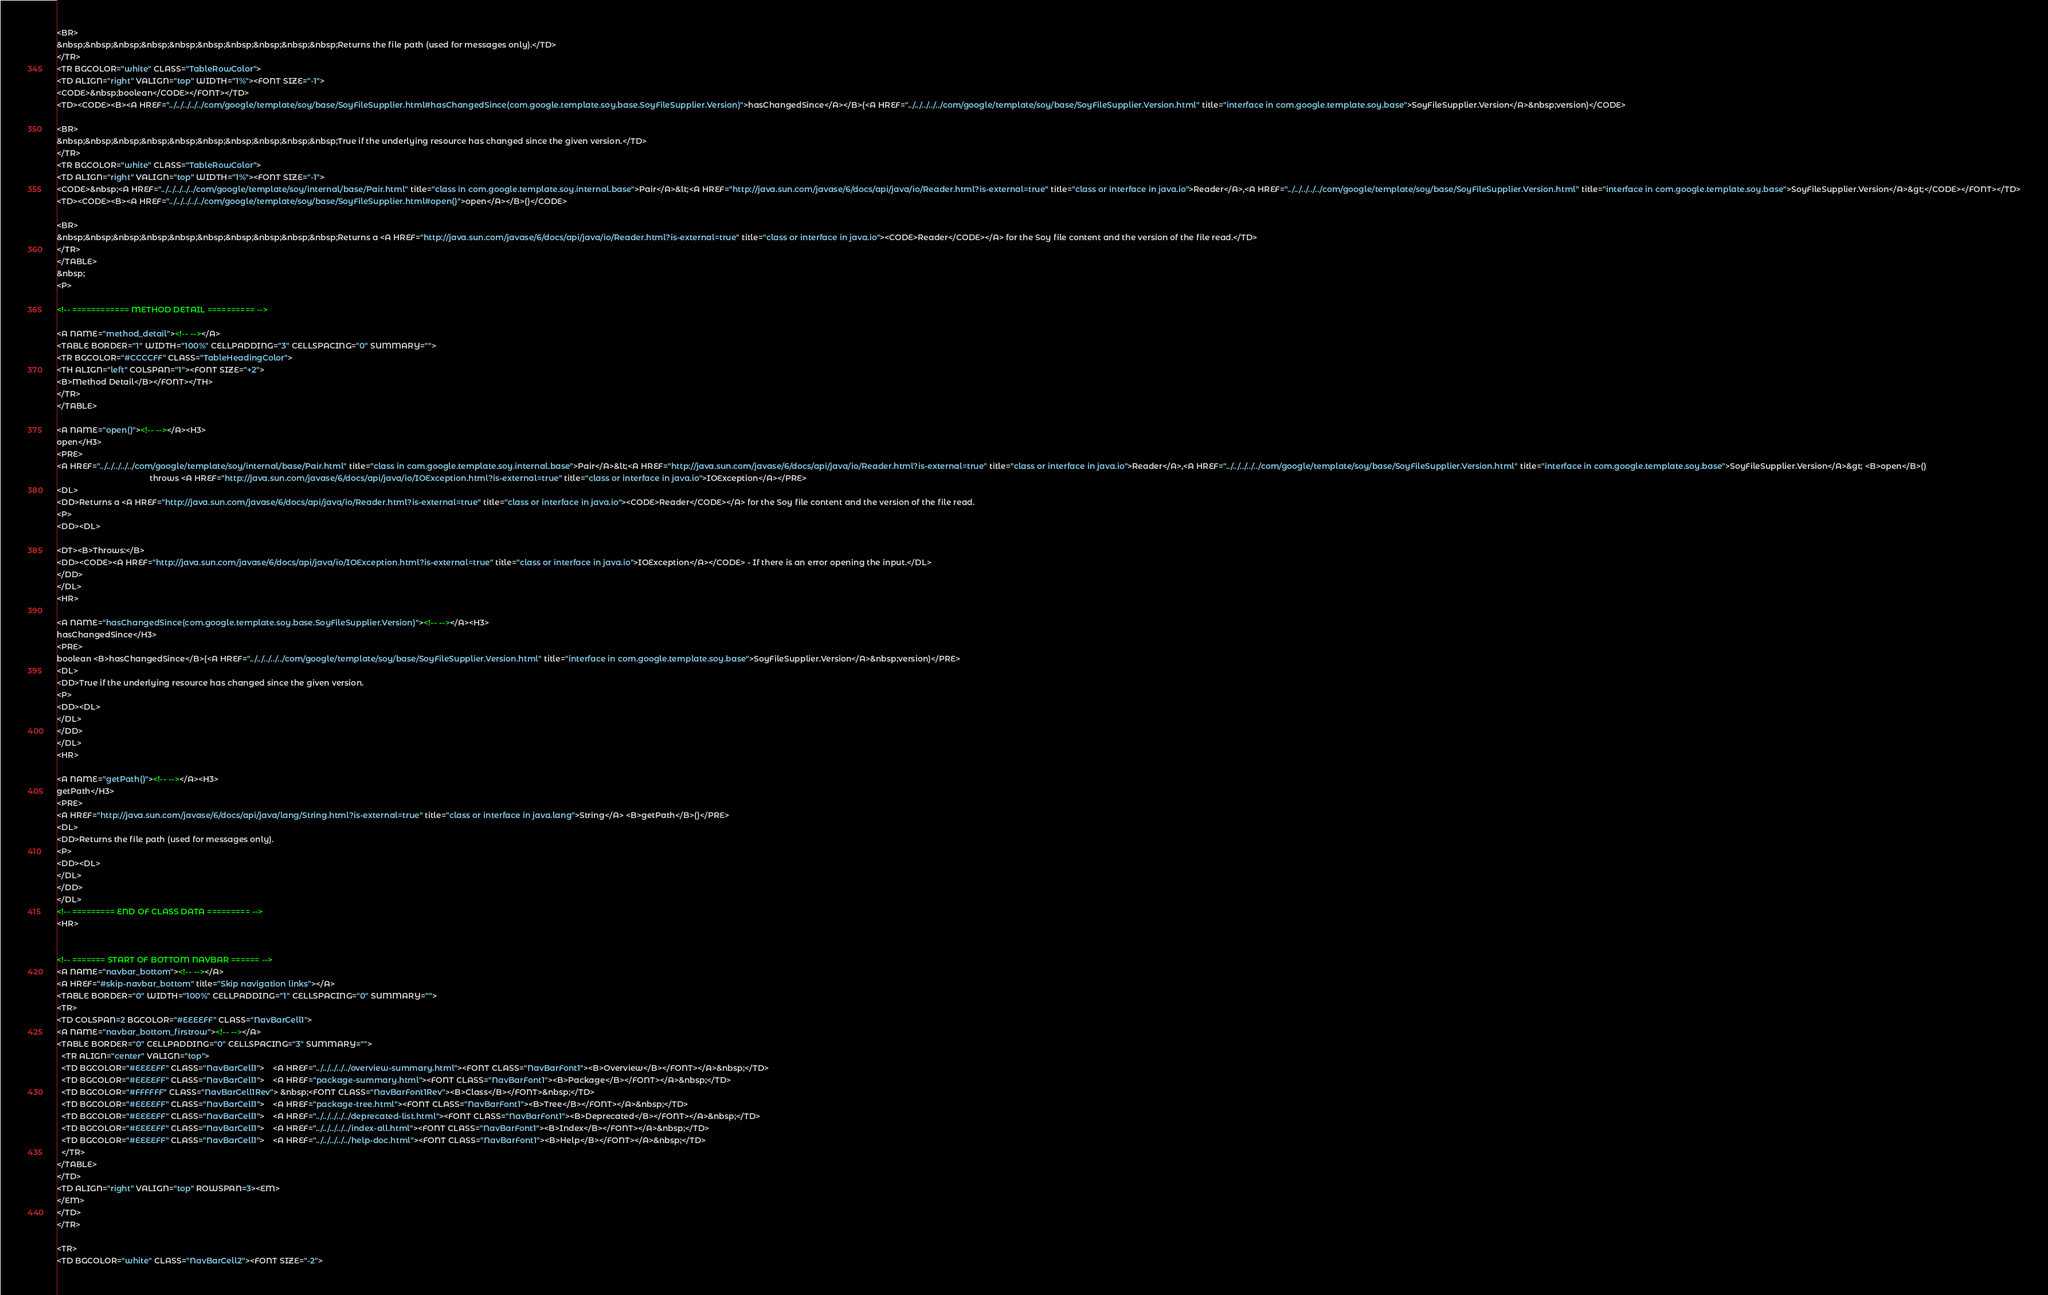Convert code to text. <code><loc_0><loc_0><loc_500><loc_500><_HTML_><BR>
&nbsp;&nbsp;&nbsp;&nbsp;&nbsp;&nbsp;&nbsp;&nbsp;&nbsp;&nbsp;Returns the file path (used for messages only).</TD>
</TR>
<TR BGCOLOR="white" CLASS="TableRowColor">
<TD ALIGN="right" VALIGN="top" WIDTH="1%"><FONT SIZE="-1">
<CODE>&nbsp;boolean</CODE></FONT></TD>
<TD><CODE><B><A HREF="../../../../../com/google/template/soy/base/SoyFileSupplier.html#hasChangedSince(com.google.template.soy.base.SoyFileSupplier.Version)">hasChangedSince</A></B>(<A HREF="../../../../../com/google/template/soy/base/SoyFileSupplier.Version.html" title="interface in com.google.template.soy.base">SoyFileSupplier.Version</A>&nbsp;version)</CODE>

<BR>
&nbsp;&nbsp;&nbsp;&nbsp;&nbsp;&nbsp;&nbsp;&nbsp;&nbsp;&nbsp;True if the underlying resource has changed since the given version.</TD>
</TR>
<TR BGCOLOR="white" CLASS="TableRowColor">
<TD ALIGN="right" VALIGN="top" WIDTH="1%"><FONT SIZE="-1">
<CODE>&nbsp;<A HREF="../../../../../com/google/template/soy/internal/base/Pair.html" title="class in com.google.template.soy.internal.base">Pair</A>&lt;<A HREF="http://java.sun.com/javase/6/docs/api/java/io/Reader.html?is-external=true" title="class or interface in java.io">Reader</A>,<A HREF="../../../../../com/google/template/soy/base/SoyFileSupplier.Version.html" title="interface in com.google.template.soy.base">SoyFileSupplier.Version</A>&gt;</CODE></FONT></TD>
<TD><CODE><B><A HREF="../../../../../com/google/template/soy/base/SoyFileSupplier.html#open()">open</A></B>()</CODE>

<BR>
&nbsp;&nbsp;&nbsp;&nbsp;&nbsp;&nbsp;&nbsp;&nbsp;&nbsp;&nbsp;Returns a <A HREF="http://java.sun.com/javase/6/docs/api/java/io/Reader.html?is-external=true" title="class or interface in java.io"><CODE>Reader</CODE></A> for the Soy file content and the version of the file read.</TD>
</TR>
</TABLE>
&nbsp;
<P>

<!-- ============ METHOD DETAIL ========== -->

<A NAME="method_detail"><!-- --></A>
<TABLE BORDER="1" WIDTH="100%" CELLPADDING="3" CELLSPACING="0" SUMMARY="">
<TR BGCOLOR="#CCCCFF" CLASS="TableHeadingColor">
<TH ALIGN="left" COLSPAN="1"><FONT SIZE="+2">
<B>Method Detail</B></FONT></TH>
</TR>
</TABLE>

<A NAME="open()"><!-- --></A><H3>
open</H3>
<PRE>
<A HREF="../../../../../com/google/template/soy/internal/base/Pair.html" title="class in com.google.template.soy.internal.base">Pair</A>&lt;<A HREF="http://java.sun.com/javase/6/docs/api/java/io/Reader.html?is-external=true" title="class or interface in java.io">Reader</A>,<A HREF="../../../../../com/google/template/soy/base/SoyFileSupplier.Version.html" title="interface in com.google.template.soy.base">SoyFileSupplier.Version</A>&gt; <B>open</B>()
                                          throws <A HREF="http://java.sun.com/javase/6/docs/api/java/io/IOException.html?is-external=true" title="class or interface in java.io">IOException</A></PRE>
<DL>
<DD>Returns a <A HREF="http://java.sun.com/javase/6/docs/api/java/io/Reader.html?is-external=true" title="class or interface in java.io"><CODE>Reader</CODE></A> for the Soy file content and the version of the file read.
<P>
<DD><DL>

<DT><B>Throws:</B>
<DD><CODE><A HREF="http://java.sun.com/javase/6/docs/api/java/io/IOException.html?is-external=true" title="class or interface in java.io">IOException</A></CODE> - If there is an error opening the input.</DL>
</DD>
</DL>
<HR>

<A NAME="hasChangedSince(com.google.template.soy.base.SoyFileSupplier.Version)"><!-- --></A><H3>
hasChangedSince</H3>
<PRE>
boolean <B>hasChangedSince</B>(<A HREF="../../../../../com/google/template/soy/base/SoyFileSupplier.Version.html" title="interface in com.google.template.soy.base">SoyFileSupplier.Version</A>&nbsp;version)</PRE>
<DL>
<DD>True if the underlying resource has changed since the given version.
<P>
<DD><DL>
</DL>
</DD>
</DL>
<HR>

<A NAME="getPath()"><!-- --></A><H3>
getPath</H3>
<PRE>
<A HREF="http://java.sun.com/javase/6/docs/api/java/lang/String.html?is-external=true" title="class or interface in java.lang">String</A> <B>getPath</B>()</PRE>
<DL>
<DD>Returns the file path (used for messages only).
<P>
<DD><DL>
</DL>
</DD>
</DL>
<!-- ========= END OF CLASS DATA ========= -->
<HR>


<!-- ======= START OF BOTTOM NAVBAR ====== -->
<A NAME="navbar_bottom"><!-- --></A>
<A HREF="#skip-navbar_bottom" title="Skip navigation links"></A>
<TABLE BORDER="0" WIDTH="100%" CELLPADDING="1" CELLSPACING="0" SUMMARY="">
<TR>
<TD COLSPAN=2 BGCOLOR="#EEEEFF" CLASS="NavBarCell1">
<A NAME="navbar_bottom_firstrow"><!-- --></A>
<TABLE BORDER="0" CELLPADDING="0" CELLSPACING="3" SUMMARY="">
  <TR ALIGN="center" VALIGN="top">
  <TD BGCOLOR="#EEEEFF" CLASS="NavBarCell1">    <A HREF="../../../../../overview-summary.html"><FONT CLASS="NavBarFont1"><B>Overview</B></FONT></A>&nbsp;</TD>
  <TD BGCOLOR="#EEEEFF" CLASS="NavBarCell1">    <A HREF="package-summary.html"><FONT CLASS="NavBarFont1"><B>Package</B></FONT></A>&nbsp;</TD>
  <TD BGCOLOR="#FFFFFF" CLASS="NavBarCell1Rev"> &nbsp;<FONT CLASS="NavBarFont1Rev"><B>Class</B></FONT>&nbsp;</TD>
  <TD BGCOLOR="#EEEEFF" CLASS="NavBarCell1">    <A HREF="package-tree.html"><FONT CLASS="NavBarFont1"><B>Tree</B></FONT></A>&nbsp;</TD>
  <TD BGCOLOR="#EEEEFF" CLASS="NavBarCell1">    <A HREF="../../../../../deprecated-list.html"><FONT CLASS="NavBarFont1"><B>Deprecated</B></FONT></A>&nbsp;</TD>
  <TD BGCOLOR="#EEEEFF" CLASS="NavBarCell1">    <A HREF="../../../../../index-all.html"><FONT CLASS="NavBarFont1"><B>Index</B></FONT></A>&nbsp;</TD>
  <TD BGCOLOR="#EEEEFF" CLASS="NavBarCell1">    <A HREF="../../../../../help-doc.html"><FONT CLASS="NavBarFont1"><B>Help</B></FONT></A>&nbsp;</TD>
  </TR>
</TABLE>
</TD>
<TD ALIGN="right" VALIGN="top" ROWSPAN=3><EM>
</EM>
</TD>
</TR>

<TR>
<TD BGCOLOR="white" CLASS="NavBarCell2"><FONT SIZE="-2"></code> 